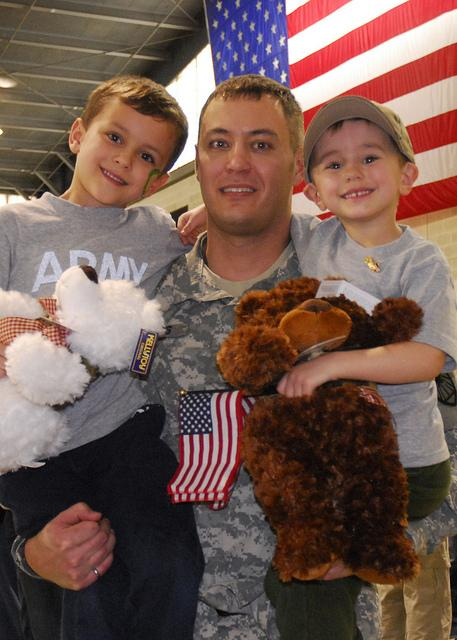What is the man's job? soldier 